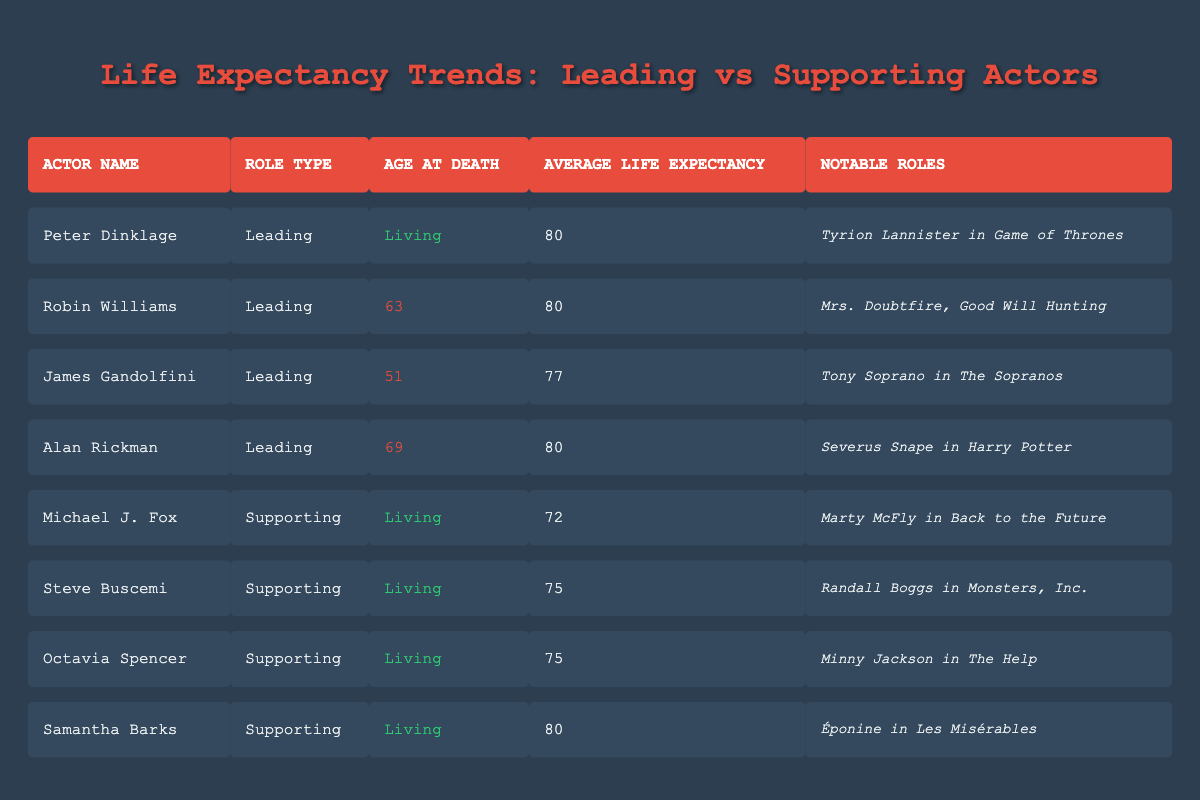What is the average life expectancy for actors in leading roles? To find this, we look at the actors in leading roles: Peter Dinklage, Robin Williams, James Gandolfini, Alan Rickman. Their average life expectancy values are 80, 80, 77, and 80. We sum these values: (80 + 80 + 77 + 80) = 317. There are 4 actors, so we divide 317 by 4, which gives us 79.25, rounded to 79 if needed.
Answer: 79.25 How many actors in the table have a known age at death? We scan the table for the age at death column and count the entries that are not marked as living. The actors with known ages at death are Robin Williams (63), James Gandolfini (51), and Alan Rickman (69), making a total of 3 actors.
Answer: 3 Is Peter Dinklage listed as a supporting actor? We check the role type of Peter Dinklage in the table. He is categorized as a leading actor, not a supporting actor. Therefore, the statement is false.
Answer: No What is the difference in average life expectancy between leading and supporting actors? First, we calculate the average life expectancy for leading actors: (80 + 80 + 77 + 80) = 317, divided by 4 gives us 79.25. For supporting actors: (72 + 75 + 75 + 80) = 302, divided by 4 gives us 75.5. Now we find the difference: 79.25 - 75.5 = 3.75.
Answer: 3.75 Who had the highest average life expectancy among the leading roles? Checking the life expectancy values for leading actors, we see Peter Dinklage, Robin Williams, and Alan Rickman all have 80, while James Gandolfini has 77. Therefore, anyone from the first three is tied for the highest average life expectancy at 80.
Answer: Peter Dinklage, Robin Williams, Alan Rickman What percentage of the actors in the table are still living? There are 8 actors listed, and 5 of them are noted as living (Peter Dinklage, Michael J. Fox, Steve Buscemi, Octavia Spencer, and Samantha Barks). To find the percentage, we use the formula (number of living actors/total actors) * 100. So (5/8) * 100 = 62.5%.
Answer: 62.5% Is Alan Rickman listed among supporting actors? We verify Alan Rickman’s role type in the table, which is classified as a leading actor. Thus, the statement is false.
Answer: No Which supporting actor has the same average life expectancy as Peter Dinklage? From the table, we see that Peter Dinklage has an average life expectancy of 80. Among supporting actors, Samantha Barks also has an average life expectancy of 80.
Answer: Samantha Barks 